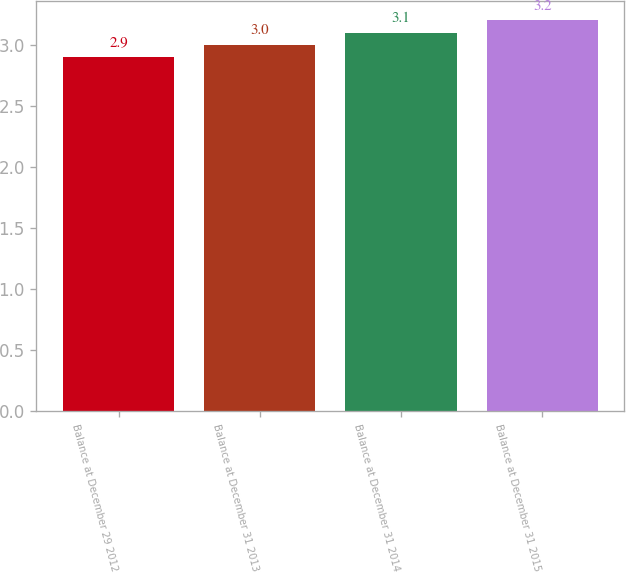Convert chart. <chart><loc_0><loc_0><loc_500><loc_500><bar_chart><fcel>Balance at December 29 2012<fcel>Balance at December 31 2013<fcel>Balance at December 31 2014<fcel>Balance at December 31 2015<nl><fcel>2.9<fcel>3<fcel>3.1<fcel>3.2<nl></chart> 